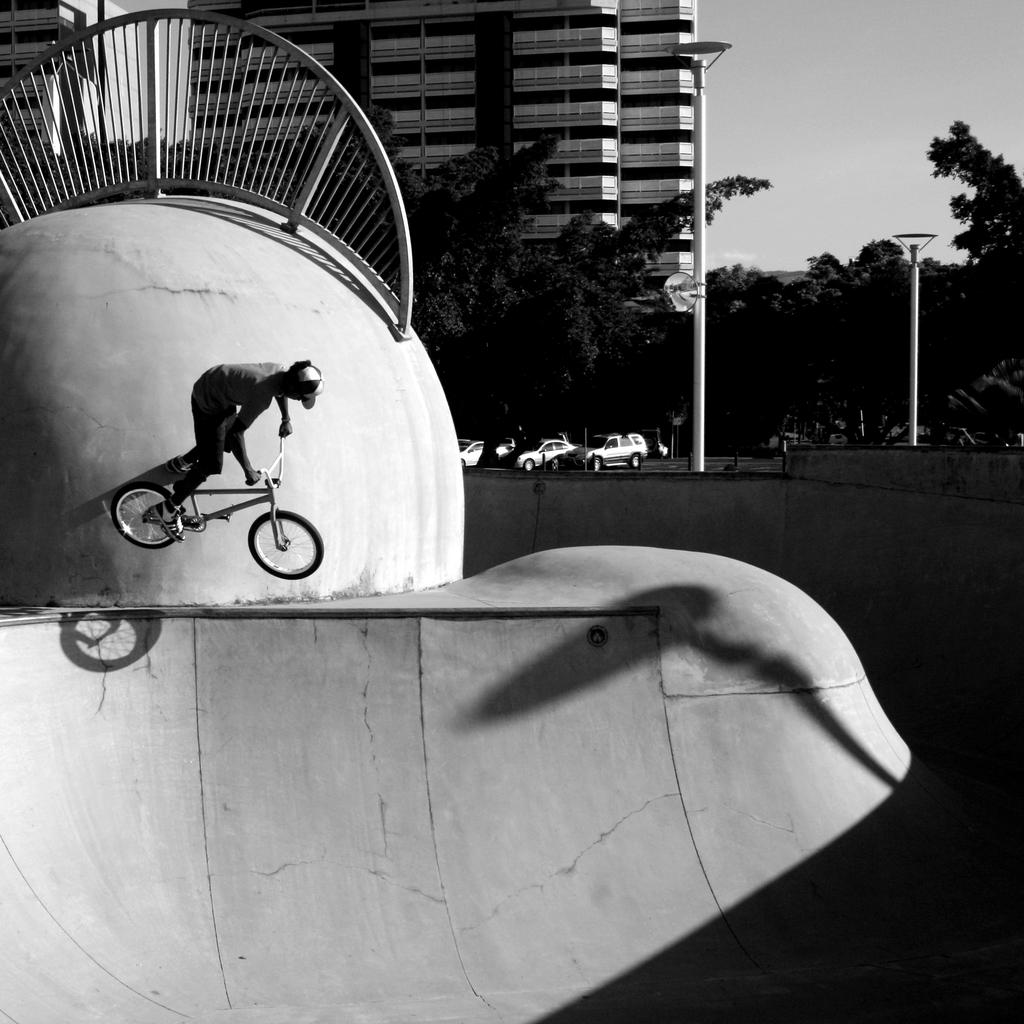What is the person in the image doing? The person is riding a bicycle in the image. Where is the person riding the bicycle? The person is on a cycling track. What can be seen in the background of the image? There are vehicles, buildings, trees, electric poles, and the sky visible in the background of the image. What type of soup is being cooked in the oven in the image? There is no oven or soup present in the image; it features a person riding a bicycle on a cycling track with various background elements. 